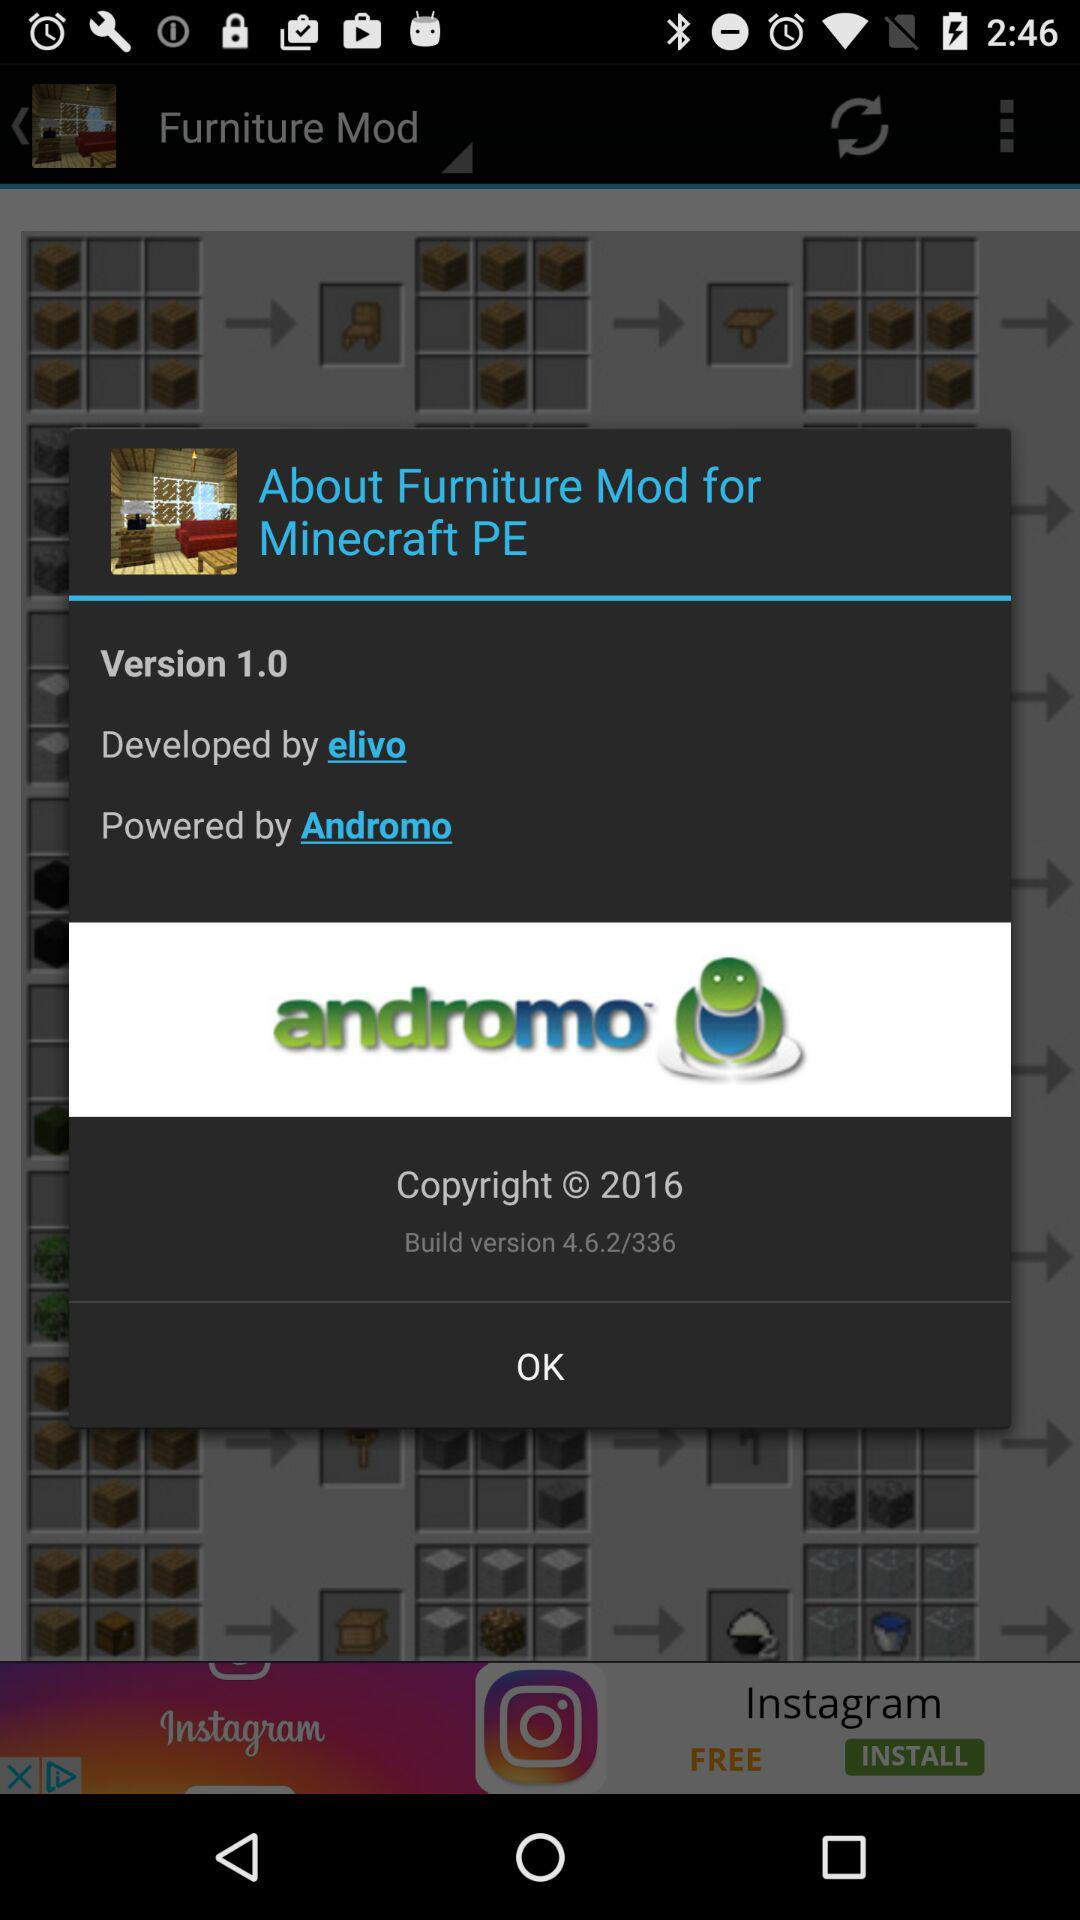By whom is the "Furniture Mod" powered? It is powered by "Andromo". 